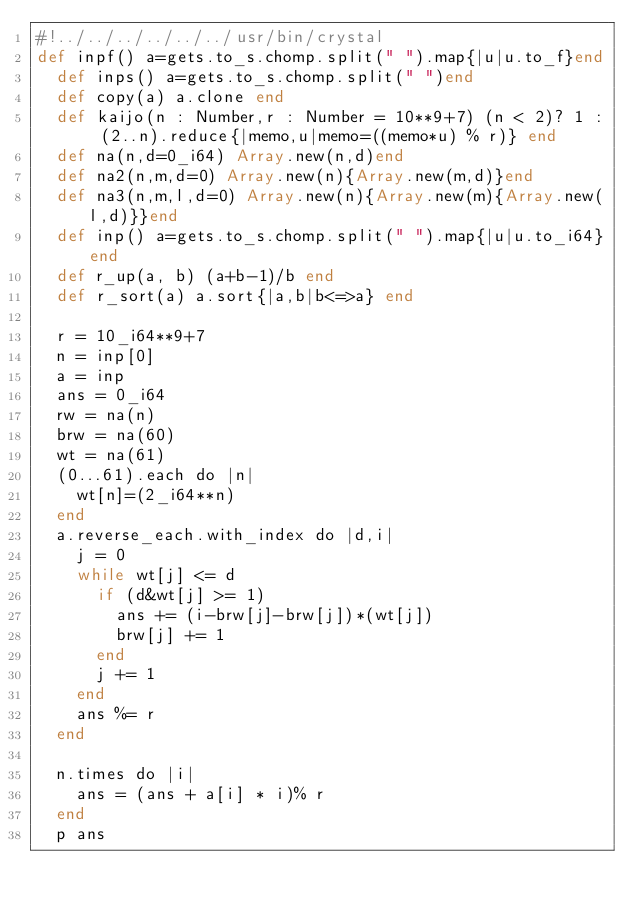Convert code to text. <code><loc_0><loc_0><loc_500><loc_500><_Crystal_>#!../../../../../../usr/bin/crystal
def inpf() a=gets.to_s.chomp.split(" ").map{|u|u.to_f}end
  def inps() a=gets.to_s.chomp.split(" ")end
  def copy(a) a.clone end
  def kaijo(n : Number,r : Number = 10**9+7) (n < 2)? 1 : (2..n).reduce{|memo,u|memo=((memo*u) % r)} end
  def na(n,d=0_i64) Array.new(n,d)end
  def na2(n,m,d=0) Array.new(n){Array.new(m,d)}end
  def na3(n,m,l,d=0) Array.new(n){Array.new(m){Array.new(l,d)}}end
  def inp() a=gets.to_s.chomp.split(" ").map{|u|u.to_i64}end
  def r_up(a, b) (a+b-1)/b end
  def r_sort(a) a.sort{|a,b|b<=>a} end

  r = 10_i64**9+7
  n = inp[0]
  a = inp
  ans = 0_i64
  rw = na(n)
  brw = na(60)
  wt = na(61)
  (0...61).each do |n|
    wt[n]=(2_i64**n)
  end
  a.reverse_each.with_index do |d,i|
    j = 0
    while wt[j] <= d
      if (d&wt[j] >= 1)
        ans += (i-brw[j]-brw[j])*(wt[j])
        brw[j] += 1
      end
      j += 1
    end
    ans %= r
  end
  
  n.times do |i|
    ans = (ans + a[i] * i)% r
  end
  p ans
  
</code> 